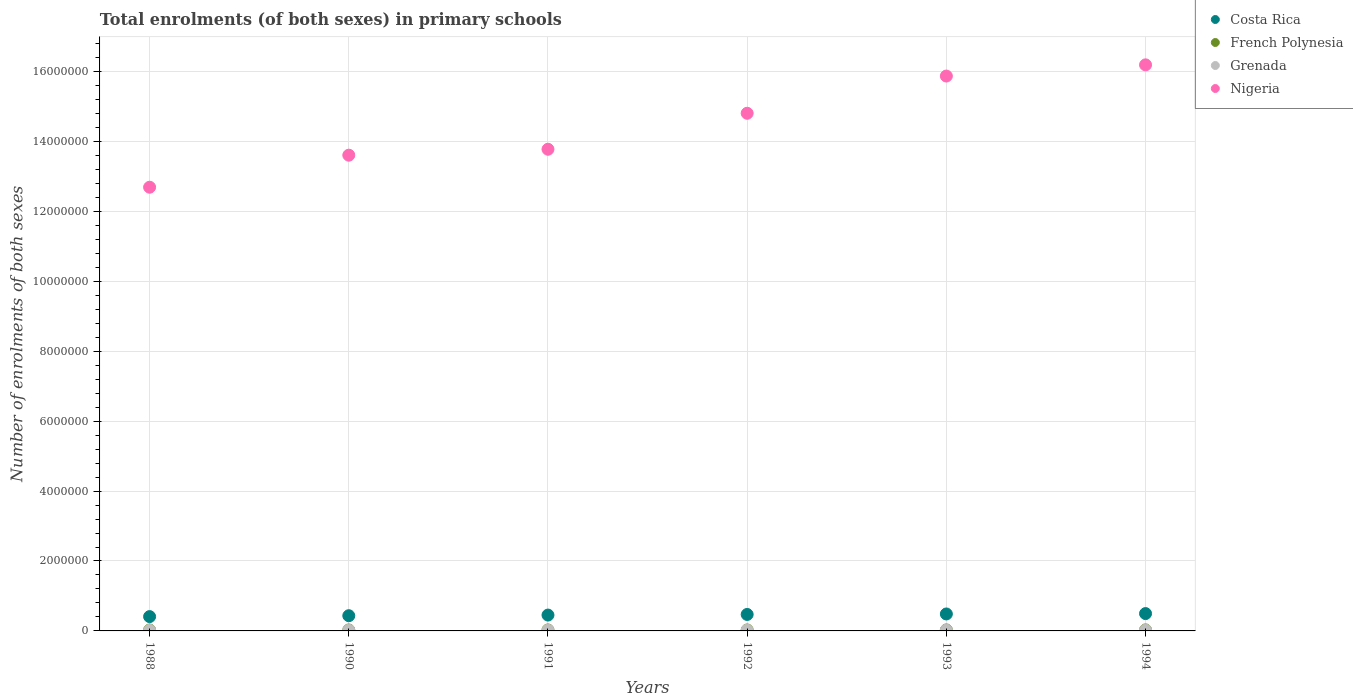Is the number of dotlines equal to the number of legend labels?
Give a very brief answer. Yes. What is the number of enrolments in primary schools in Costa Rica in 1993?
Your answer should be very brief. 4.85e+05. Across all years, what is the maximum number of enrolments in primary schools in Nigeria?
Offer a very short reply. 1.62e+07. Across all years, what is the minimum number of enrolments in primary schools in Nigeria?
Keep it short and to the point. 1.27e+07. In which year was the number of enrolments in primary schools in Nigeria maximum?
Your answer should be very brief. 1994. What is the total number of enrolments in primary schools in Grenada in the graph?
Your response must be concise. 1.24e+05. What is the difference between the number of enrolments in primary schools in Nigeria in 1990 and that in 1993?
Ensure brevity in your answer.  -2.26e+06. What is the difference between the number of enrolments in primary schools in Grenada in 1991 and the number of enrolments in primary schools in French Polynesia in 1992?
Your answer should be very brief. -8384. What is the average number of enrolments in primary schools in Nigeria per year?
Keep it short and to the point. 1.45e+07. In the year 1991, what is the difference between the number of enrolments in primary schools in Costa Rica and number of enrolments in primary schools in Grenada?
Offer a very short reply. 4.33e+05. In how many years, is the number of enrolments in primary schools in Grenada greater than 8400000?
Ensure brevity in your answer.  0. What is the ratio of the number of enrolments in primary schools in French Polynesia in 1993 to that in 1994?
Ensure brevity in your answer.  0.98. Is the difference between the number of enrolments in primary schools in Costa Rica in 1990 and 1994 greater than the difference between the number of enrolments in primary schools in Grenada in 1990 and 1994?
Offer a very short reply. No. What is the difference between the highest and the second highest number of enrolments in primary schools in French Polynesia?
Provide a succinct answer. 468. What is the difference between the highest and the lowest number of enrolments in primary schools in Costa Rica?
Your response must be concise. 8.63e+04. In how many years, is the number of enrolments in primary schools in Nigeria greater than the average number of enrolments in primary schools in Nigeria taken over all years?
Give a very brief answer. 3. Is the sum of the number of enrolments in primary schools in French Polynesia in 1990 and 1994 greater than the maximum number of enrolments in primary schools in Nigeria across all years?
Offer a very short reply. No. Is it the case that in every year, the sum of the number of enrolments in primary schools in Nigeria and number of enrolments in primary schools in Costa Rica  is greater than the sum of number of enrolments in primary schools in Grenada and number of enrolments in primary schools in French Polynesia?
Give a very brief answer. Yes. How many years are there in the graph?
Offer a very short reply. 6. Does the graph contain grids?
Offer a terse response. Yes. Where does the legend appear in the graph?
Make the answer very short. Top right. What is the title of the graph?
Ensure brevity in your answer.  Total enrolments (of both sexes) in primary schools. What is the label or title of the X-axis?
Offer a very short reply. Years. What is the label or title of the Y-axis?
Offer a very short reply. Number of enrolments of both sexes. What is the Number of enrolments of both sexes in Costa Rica in 1988?
Give a very brief answer. 4.10e+05. What is the Number of enrolments of both sexes of French Polynesia in 1988?
Provide a short and direct response. 2.73e+04. What is the Number of enrolments of both sexes of Grenada in 1988?
Offer a very short reply. 1.82e+04. What is the Number of enrolments of both sexes in Nigeria in 1988?
Make the answer very short. 1.27e+07. What is the Number of enrolments of both sexes of Costa Rica in 1990?
Make the answer very short. 4.35e+05. What is the Number of enrolments of both sexes of French Polynesia in 1990?
Ensure brevity in your answer.  2.79e+04. What is the Number of enrolments of both sexes of Grenada in 1990?
Your response must be concise. 1.92e+04. What is the Number of enrolments of both sexes of Nigeria in 1990?
Give a very brief answer. 1.36e+07. What is the Number of enrolments of both sexes of Costa Rica in 1991?
Provide a succinct answer. 4.53e+05. What is the Number of enrolments of both sexes in French Polynesia in 1991?
Keep it short and to the point. 2.83e+04. What is the Number of enrolments of both sexes in Grenada in 1991?
Make the answer very short. 1.98e+04. What is the Number of enrolments of both sexes of Nigeria in 1991?
Provide a short and direct response. 1.38e+07. What is the Number of enrolments of both sexes of Costa Rica in 1992?
Keep it short and to the point. 4.71e+05. What is the Number of enrolments of both sexes in French Polynesia in 1992?
Provide a short and direct response. 2.82e+04. What is the Number of enrolments of both sexes in Grenada in 1992?
Make the answer very short. 2.14e+04. What is the Number of enrolments of both sexes in Nigeria in 1992?
Provide a short and direct response. 1.48e+07. What is the Number of enrolments of both sexes of Costa Rica in 1993?
Your answer should be very brief. 4.85e+05. What is the Number of enrolments of both sexes of French Polynesia in 1993?
Your answer should be very brief. 2.91e+04. What is the Number of enrolments of both sexes of Grenada in 1993?
Your response must be concise. 2.23e+04. What is the Number of enrolments of both sexes in Nigeria in 1993?
Offer a terse response. 1.59e+07. What is the Number of enrolments of both sexes of Costa Rica in 1994?
Your answer should be compact. 4.96e+05. What is the Number of enrolments of both sexes in French Polynesia in 1994?
Provide a short and direct response. 2.96e+04. What is the Number of enrolments of both sexes of Grenada in 1994?
Offer a very short reply. 2.26e+04. What is the Number of enrolments of both sexes in Nigeria in 1994?
Provide a short and direct response. 1.62e+07. Across all years, what is the maximum Number of enrolments of both sexes in Costa Rica?
Your answer should be compact. 4.96e+05. Across all years, what is the maximum Number of enrolments of both sexes of French Polynesia?
Provide a succinct answer. 2.96e+04. Across all years, what is the maximum Number of enrolments of both sexes in Grenada?
Your response must be concise. 2.26e+04. Across all years, what is the maximum Number of enrolments of both sexes in Nigeria?
Provide a succinct answer. 1.62e+07. Across all years, what is the minimum Number of enrolments of both sexes in Costa Rica?
Provide a short and direct response. 4.10e+05. Across all years, what is the minimum Number of enrolments of both sexes in French Polynesia?
Keep it short and to the point. 2.73e+04. Across all years, what is the minimum Number of enrolments of both sexes in Grenada?
Offer a very short reply. 1.82e+04. Across all years, what is the minimum Number of enrolments of both sexes of Nigeria?
Your answer should be compact. 1.27e+07. What is the total Number of enrolments of both sexes in Costa Rica in the graph?
Your response must be concise. 2.75e+06. What is the total Number of enrolments of both sexes of French Polynesia in the graph?
Give a very brief answer. 1.70e+05. What is the total Number of enrolments of both sexes in Grenada in the graph?
Provide a succinct answer. 1.24e+05. What is the total Number of enrolments of both sexes in Nigeria in the graph?
Give a very brief answer. 8.69e+07. What is the difference between the Number of enrolments of both sexes in Costa Rica in 1988 and that in 1990?
Offer a very short reply. -2.56e+04. What is the difference between the Number of enrolments of both sexes in French Polynesia in 1988 and that in 1990?
Keep it short and to the point. -595. What is the difference between the Number of enrolments of both sexes of Grenada in 1988 and that in 1990?
Offer a terse response. -949. What is the difference between the Number of enrolments of both sexes of Nigeria in 1988 and that in 1990?
Offer a very short reply. -9.16e+05. What is the difference between the Number of enrolments of both sexes in Costa Rica in 1988 and that in 1991?
Offer a terse response. -4.37e+04. What is the difference between the Number of enrolments of both sexes of French Polynesia in 1988 and that in 1991?
Keep it short and to the point. -1011. What is the difference between the Number of enrolments of both sexes in Grenada in 1988 and that in 1991?
Provide a succinct answer. -1580. What is the difference between the Number of enrolments of both sexes in Nigeria in 1988 and that in 1991?
Keep it short and to the point. -1.09e+06. What is the difference between the Number of enrolments of both sexes in Costa Rica in 1988 and that in 1992?
Give a very brief answer. -6.14e+04. What is the difference between the Number of enrolments of both sexes of French Polynesia in 1988 and that in 1992?
Keep it short and to the point. -936. What is the difference between the Number of enrolments of both sexes of Grenada in 1988 and that in 1992?
Your response must be concise. -3134. What is the difference between the Number of enrolments of both sexes of Nigeria in 1988 and that in 1992?
Your answer should be compact. -2.12e+06. What is the difference between the Number of enrolments of both sexes in Costa Rica in 1988 and that in 1993?
Keep it short and to the point. -7.53e+04. What is the difference between the Number of enrolments of both sexes of French Polynesia in 1988 and that in 1993?
Make the answer very short. -1873. What is the difference between the Number of enrolments of both sexes in Grenada in 1988 and that in 1993?
Make the answer very short. -4114. What is the difference between the Number of enrolments of both sexes in Nigeria in 1988 and that in 1993?
Your answer should be compact. -3.18e+06. What is the difference between the Number of enrolments of both sexes in Costa Rica in 1988 and that in 1994?
Keep it short and to the point. -8.63e+04. What is the difference between the Number of enrolments of both sexes of French Polynesia in 1988 and that in 1994?
Your answer should be compact. -2341. What is the difference between the Number of enrolments of both sexes of Grenada in 1988 and that in 1994?
Give a very brief answer. -4345. What is the difference between the Number of enrolments of both sexes of Nigeria in 1988 and that in 1994?
Offer a very short reply. -3.50e+06. What is the difference between the Number of enrolments of both sexes in Costa Rica in 1990 and that in 1991?
Your answer should be compact. -1.81e+04. What is the difference between the Number of enrolments of both sexes in French Polynesia in 1990 and that in 1991?
Offer a very short reply. -416. What is the difference between the Number of enrolments of both sexes of Grenada in 1990 and that in 1991?
Offer a very short reply. -631. What is the difference between the Number of enrolments of both sexes of Nigeria in 1990 and that in 1991?
Keep it short and to the point. -1.70e+05. What is the difference between the Number of enrolments of both sexes of Costa Rica in 1990 and that in 1992?
Provide a short and direct response. -3.58e+04. What is the difference between the Number of enrolments of both sexes of French Polynesia in 1990 and that in 1992?
Ensure brevity in your answer.  -341. What is the difference between the Number of enrolments of both sexes in Grenada in 1990 and that in 1992?
Your response must be concise. -2185. What is the difference between the Number of enrolments of both sexes of Nigeria in 1990 and that in 1992?
Offer a very short reply. -1.20e+06. What is the difference between the Number of enrolments of both sexes of Costa Rica in 1990 and that in 1993?
Provide a short and direct response. -4.98e+04. What is the difference between the Number of enrolments of both sexes of French Polynesia in 1990 and that in 1993?
Offer a terse response. -1278. What is the difference between the Number of enrolments of both sexes in Grenada in 1990 and that in 1993?
Your response must be concise. -3165. What is the difference between the Number of enrolments of both sexes in Nigeria in 1990 and that in 1993?
Provide a short and direct response. -2.26e+06. What is the difference between the Number of enrolments of both sexes in Costa Rica in 1990 and that in 1994?
Your answer should be very brief. -6.07e+04. What is the difference between the Number of enrolments of both sexes in French Polynesia in 1990 and that in 1994?
Your answer should be very brief. -1746. What is the difference between the Number of enrolments of both sexes of Grenada in 1990 and that in 1994?
Your answer should be compact. -3396. What is the difference between the Number of enrolments of both sexes of Nigeria in 1990 and that in 1994?
Your answer should be compact. -2.58e+06. What is the difference between the Number of enrolments of both sexes in Costa Rica in 1991 and that in 1992?
Give a very brief answer. -1.78e+04. What is the difference between the Number of enrolments of both sexes in French Polynesia in 1991 and that in 1992?
Keep it short and to the point. 75. What is the difference between the Number of enrolments of both sexes in Grenada in 1991 and that in 1992?
Your answer should be compact. -1554. What is the difference between the Number of enrolments of both sexes of Nigeria in 1991 and that in 1992?
Give a very brief answer. -1.03e+06. What is the difference between the Number of enrolments of both sexes in Costa Rica in 1991 and that in 1993?
Make the answer very short. -3.17e+04. What is the difference between the Number of enrolments of both sexes in French Polynesia in 1991 and that in 1993?
Your answer should be compact. -862. What is the difference between the Number of enrolments of both sexes of Grenada in 1991 and that in 1993?
Ensure brevity in your answer.  -2534. What is the difference between the Number of enrolments of both sexes in Nigeria in 1991 and that in 1993?
Keep it short and to the point. -2.09e+06. What is the difference between the Number of enrolments of both sexes in Costa Rica in 1991 and that in 1994?
Give a very brief answer. -4.26e+04. What is the difference between the Number of enrolments of both sexes in French Polynesia in 1991 and that in 1994?
Make the answer very short. -1330. What is the difference between the Number of enrolments of both sexes of Grenada in 1991 and that in 1994?
Make the answer very short. -2765. What is the difference between the Number of enrolments of both sexes of Nigeria in 1991 and that in 1994?
Keep it short and to the point. -2.41e+06. What is the difference between the Number of enrolments of both sexes in Costa Rica in 1992 and that in 1993?
Keep it short and to the point. -1.39e+04. What is the difference between the Number of enrolments of both sexes of French Polynesia in 1992 and that in 1993?
Provide a short and direct response. -937. What is the difference between the Number of enrolments of both sexes in Grenada in 1992 and that in 1993?
Your answer should be compact. -980. What is the difference between the Number of enrolments of both sexes of Nigeria in 1992 and that in 1993?
Your answer should be compact. -1.06e+06. What is the difference between the Number of enrolments of both sexes in Costa Rica in 1992 and that in 1994?
Your answer should be very brief. -2.48e+04. What is the difference between the Number of enrolments of both sexes in French Polynesia in 1992 and that in 1994?
Ensure brevity in your answer.  -1405. What is the difference between the Number of enrolments of both sexes of Grenada in 1992 and that in 1994?
Your response must be concise. -1211. What is the difference between the Number of enrolments of both sexes of Nigeria in 1992 and that in 1994?
Offer a terse response. -1.39e+06. What is the difference between the Number of enrolments of both sexes of Costa Rica in 1993 and that in 1994?
Offer a terse response. -1.09e+04. What is the difference between the Number of enrolments of both sexes in French Polynesia in 1993 and that in 1994?
Offer a terse response. -468. What is the difference between the Number of enrolments of both sexes of Grenada in 1993 and that in 1994?
Provide a short and direct response. -231. What is the difference between the Number of enrolments of both sexes in Nigeria in 1993 and that in 1994?
Your response must be concise. -3.21e+05. What is the difference between the Number of enrolments of both sexes of Costa Rica in 1988 and the Number of enrolments of both sexes of French Polynesia in 1990?
Your answer should be compact. 3.82e+05. What is the difference between the Number of enrolments of both sexes of Costa Rica in 1988 and the Number of enrolments of both sexes of Grenada in 1990?
Your answer should be compact. 3.90e+05. What is the difference between the Number of enrolments of both sexes in Costa Rica in 1988 and the Number of enrolments of both sexes in Nigeria in 1990?
Ensure brevity in your answer.  -1.32e+07. What is the difference between the Number of enrolments of both sexes of French Polynesia in 1988 and the Number of enrolments of both sexes of Grenada in 1990?
Make the answer very short. 8079. What is the difference between the Number of enrolments of both sexes in French Polynesia in 1988 and the Number of enrolments of both sexes in Nigeria in 1990?
Make the answer very short. -1.36e+07. What is the difference between the Number of enrolments of both sexes of Grenada in 1988 and the Number of enrolments of both sexes of Nigeria in 1990?
Keep it short and to the point. -1.36e+07. What is the difference between the Number of enrolments of both sexes of Costa Rica in 1988 and the Number of enrolments of both sexes of French Polynesia in 1991?
Give a very brief answer. 3.81e+05. What is the difference between the Number of enrolments of both sexes in Costa Rica in 1988 and the Number of enrolments of both sexes in Grenada in 1991?
Your answer should be compact. 3.90e+05. What is the difference between the Number of enrolments of both sexes of Costa Rica in 1988 and the Number of enrolments of both sexes of Nigeria in 1991?
Provide a short and direct response. -1.34e+07. What is the difference between the Number of enrolments of both sexes of French Polynesia in 1988 and the Number of enrolments of both sexes of Grenada in 1991?
Make the answer very short. 7448. What is the difference between the Number of enrolments of both sexes in French Polynesia in 1988 and the Number of enrolments of both sexes in Nigeria in 1991?
Offer a terse response. -1.37e+07. What is the difference between the Number of enrolments of both sexes in Grenada in 1988 and the Number of enrolments of both sexes in Nigeria in 1991?
Make the answer very short. -1.38e+07. What is the difference between the Number of enrolments of both sexes of Costa Rica in 1988 and the Number of enrolments of both sexes of French Polynesia in 1992?
Your answer should be compact. 3.81e+05. What is the difference between the Number of enrolments of both sexes of Costa Rica in 1988 and the Number of enrolments of both sexes of Grenada in 1992?
Offer a terse response. 3.88e+05. What is the difference between the Number of enrolments of both sexes in Costa Rica in 1988 and the Number of enrolments of both sexes in Nigeria in 1992?
Keep it short and to the point. -1.44e+07. What is the difference between the Number of enrolments of both sexes in French Polynesia in 1988 and the Number of enrolments of both sexes in Grenada in 1992?
Provide a succinct answer. 5894. What is the difference between the Number of enrolments of both sexes in French Polynesia in 1988 and the Number of enrolments of both sexes in Nigeria in 1992?
Offer a very short reply. -1.48e+07. What is the difference between the Number of enrolments of both sexes of Grenada in 1988 and the Number of enrolments of both sexes of Nigeria in 1992?
Keep it short and to the point. -1.48e+07. What is the difference between the Number of enrolments of both sexes in Costa Rica in 1988 and the Number of enrolments of both sexes in French Polynesia in 1993?
Ensure brevity in your answer.  3.80e+05. What is the difference between the Number of enrolments of both sexes of Costa Rica in 1988 and the Number of enrolments of both sexes of Grenada in 1993?
Offer a terse response. 3.87e+05. What is the difference between the Number of enrolments of both sexes of Costa Rica in 1988 and the Number of enrolments of both sexes of Nigeria in 1993?
Offer a very short reply. -1.55e+07. What is the difference between the Number of enrolments of both sexes of French Polynesia in 1988 and the Number of enrolments of both sexes of Grenada in 1993?
Offer a very short reply. 4914. What is the difference between the Number of enrolments of both sexes in French Polynesia in 1988 and the Number of enrolments of both sexes in Nigeria in 1993?
Your response must be concise. -1.58e+07. What is the difference between the Number of enrolments of both sexes of Grenada in 1988 and the Number of enrolments of both sexes of Nigeria in 1993?
Give a very brief answer. -1.59e+07. What is the difference between the Number of enrolments of both sexes in Costa Rica in 1988 and the Number of enrolments of both sexes in French Polynesia in 1994?
Offer a terse response. 3.80e+05. What is the difference between the Number of enrolments of both sexes in Costa Rica in 1988 and the Number of enrolments of both sexes in Grenada in 1994?
Your response must be concise. 3.87e+05. What is the difference between the Number of enrolments of both sexes of Costa Rica in 1988 and the Number of enrolments of both sexes of Nigeria in 1994?
Offer a very short reply. -1.58e+07. What is the difference between the Number of enrolments of both sexes in French Polynesia in 1988 and the Number of enrolments of both sexes in Grenada in 1994?
Ensure brevity in your answer.  4683. What is the difference between the Number of enrolments of both sexes of French Polynesia in 1988 and the Number of enrolments of both sexes of Nigeria in 1994?
Make the answer very short. -1.62e+07. What is the difference between the Number of enrolments of both sexes in Grenada in 1988 and the Number of enrolments of both sexes in Nigeria in 1994?
Ensure brevity in your answer.  -1.62e+07. What is the difference between the Number of enrolments of both sexes of Costa Rica in 1990 and the Number of enrolments of both sexes of French Polynesia in 1991?
Offer a terse response. 4.07e+05. What is the difference between the Number of enrolments of both sexes of Costa Rica in 1990 and the Number of enrolments of both sexes of Grenada in 1991?
Keep it short and to the point. 4.15e+05. What is the difference between the Number of enrolments of both sexes in Costa Rica in 1990 and the Number of enrolments of both sexes in Nigeria in 1991?
Offer a very short reply. -1.33e+07. What is the difference between the Number of enrolments of both sexes in French Polynesia in 1990 and the Number of enrolments of both sexes in Grenada in 1991?
Your answer should be very brief. 8043. What is the difference between the Number of enrolments of both sexes in French Polynesia in 1990 and the Number of enrolments of both sexes in Nigeria in 1991?
Give a very brief answer. -1.37e+07. What is the difference between the Number of enrolments of both sexes in Grenada in 1990 and the Number of enrolments of both sexes in Nigeria in 1991?
Offer a terse response. -1.38e+07. What is the difference between the Number of enrolments of both sexes of Costa Rica in 1990 and the Number of enrolments of both sexes of French Polynesia in 1992?
Provide a succinct answer. 4.07e+05. What is the difference between the Number of enrolments of both sexes of Costa Rica in 1990 and the Number of enrolments of both sexes of Grenada in 1992?
Ensure brevity in your answer.  4.14e+05. What is the difference between the Number of enrolments of both sexes of Costa Rica in 1990 and the Number of enrolments of both sexes of Nigeria in 1992?
Ensure brevity in your answer.  -1.44e+07. What is the difference between the Number of enrolments of both sexes in French Polynesia in 1990 and the Number of enrolments of both sexes in Grenada in 1992?
Give a very brief answer. 6489. What is the difference between the Number of enrolments of both sexes in French Polynesia in 1990 and the Number of enrolments of both sexes in Nigeria in 1992?
Provide a short and direct response. -1.48e+07. What is the difference between the Number of enrolments of both sexes in Grenada in 1990 and the Number of enrolments of both sexes in Nigeria in 1992?
Your answer should be very brief. -1.48e+07. What is the difference between the Number of enrolments of both sexes in Costa Rica in 1990 and the Number of enrolments of both sexes in French Polynesia in 1993?
Make the answer very short. 4.06e+05. What is the difference between the Number of enrolments of both sexes in Costa Rica in 1990 and the Number of enrolments of both sexes in Grenada in 1993?
Keep it short and to the point. 4.13e+05. What is the difference between the Number of enrolments of both sexes of Costa Rica in 1990 and the Number of enrolments of both sexes of Nigeria in 1993?
Ensure brevity in your answer.  -1.54e+07. What is the difference between the Number of enrolments of both sexes in French Polynesia in 1990 and the Number of enrolments of both sexes in Grenada in 1993?
Give a very brief answer. 5509. What is the difference between the Number of enrolments of both sexes in French Polynesia in 1990 and the Number of enrolments of both sexes in Nigeria in 1993?
Your answer should be very brief. -1.58e+07. What is the difference between the Number of enrolments of both sexes of Grenada in 1990 and the Number of enrolments of both sexes of Nigeria in 1993?
Offer a terse response. -1.59e+07. What is the difference between the Number of enrolments of both sexes of Costa Rica in 1990 and the Number of enrolments of both sexes of French Polynesia in 1994?
Keep it short and to the point. 4.06e+05. What is the difference between the Number of enrolments of both sexes of Costa Rica in 1990 and the Number of enrolments of both sexes of Grenada in 1994?
Offer a very short reply. 4.13e+05. What is the difference between the Number of enrolments of both sexes in Costa Rica in 1990 and the Number of enrolments of both sexes in Nigeria in 1994?
Your answer should be very brief. -1.58e+07. What is the difference between the Number of enrolments of both sexes in French Polynesia in 1990 and the Number of enrolments of both sexes in Grenada in 1994?
Your response must be concise. 5278. What is the difference between the Number of enrolments of both sexes in French Polynesia in 1990 and the Number of enrolments of both sexes in Nigeria in 1994?
Give a very brief answer. -1.62e+07. What is the difference between the Number of enrolments of both sexes in Grenada in 1990 and the Number of enrolments of both sexes in Nigeria in 1994?
Your response must be concise. -1.62e+07. What is the difference between the Number of enrolments of both sexes in Costa Rica in 1991 and the Number of enrolments of both sexes in French Polynesia in 1992?
Your answer should be very brief. 4.25e+05. What is the difference between the Number of enrolments of both sexes in Costa Rica in 1991 and the Number of enrolments of both sexes in Grenada in 1992?
Offer a very short reply. 4.32e+05. What is the difference between the Number of enrolments of both sexes in Costa Rica in 1991 and the Number of enrolments of both sexes in Nigeria in 1992?
Your answer should be compact. -1.44e+07. What is the difference between the Number of enrolments of both sexes of French Polynesia in 1991 and the Number of enrolments of both sexes of Grenada in 1992?
Provide a short and direct response. 6905. What is the difference between the Number of enrolments of both sexes in French Polynesia in 1991 and the Number of enrolments of both sexes in Nigeria in 1992?
Your answer should be very brief. -1.48e+07. What is the difference between the Number of enrolments of both sexes in Grenada in 1991 and the Number of enrolments of both sexes in Nigeria in 1992?
Ensure brevity in your answer.  -1.48e+07. What is the difference between the Number of enrolments of both sexes of Costa Rica in 1991 and the Number of enrolments of both sexes of French Polynesia in 1993?
Your answer should be compact. 4.24e+05. What is the difference between the Number of enrolments of both sexes in Costa Rica in 1991 and the Number of enrolments of both sexes in Grenada in 1993?
Your answer should be compact. 4.31e+05. What is the difference between the Number of enrolments of both sexes in Costa Rica in 1991 and the Number of enrolments of both sexes in Nigeria in 1993?
Provide a succinct answer. -1.54e+07. What is the difference between the Number of enrolments of both sexes of French Polynesia in 1991 and the Number of enrolments of both sexes of Grenada in 1993?
Offer a terse response. 5925. What is the difference between the Number of enrolments of both sexes of French Polynesia in 1991 and the Number of enrolments of both sexes of Nigeria in 1993?
Keep it short and to the point. -1.58e+07. What is the difference between the Number of enrolments of both sexes in Grenada in 1991 and the Number of enrolments of both sexes in Nigeria in 1993?
Keep it short and to the point. -1.59e+07. What is the difference between the Number of enrolments of both sexes in Costa Rica in 1991 and the Number of enrolments of both sexes in French Polynesia in 1994?
Your answer should be compact. 4.24e+05. What is the difference between the Number of enrolments of both sexes of Costa Rica in 1991 and the Number of enrolments of both sexes of Grenada in 1994?
Offer a terse response. 4.31e+05. What is the difference between the Number of enrolments of both sexes of Costa Rica in 1991 and the Number of enrolments of both sexes of Nigeria in 1994?
Provide a succinct answer. -1.57e+07. What is the difference between the Number of enrolments of both sexes in French Polynesia in 1991 and the Number of enrolments of both sexes in Grenada in 1994?
Offer a very short reply. 5694. What is the difference between the Number of enrolments of both sexes in French Polynesia in 1991 and the Number of enrolments of both sexes in Nigeria in 1994?
Provide a short and direct response. -1.62e+07. What is the difference between the Number of enrolments of both sexes of Grenada in 1991 and the Number of enrolments of both sexes of Nigeria in 1994?
Your answer should be very brief. -1.62e+07. What is the difference between the Number of enrolments of both sexes in Costa Rica in 1992 and the Number of enrolments of both sexes in French Polynesia in 1993?
Give a very brief answer. 4.42e+05. What is the difference between the Number of enrolments of both sexes of Costa Rica in 1992 and the Number of enrolments of both sexes of Grenada in 1993?
Provide a short and direct response. 4.49e+05. What is the difference between the Number of enrolments of both sexes of Costa Rica in 1992 and the Number of enrolments of both sexes of Nigeria in 1993?
Give a very brief answer. -1.54e+07. What is the difference between the Number of enrolments of both sexes of French Polynesia in 1992 and the Number of enrolments of both sexes of Grenada in 1993?
Provide a succinct answer. 5850. What is the difference between the Number of enrolments of both sexes in French Polynesia in 1992 and the Number of enrolments of both sexes in Nigeria in 1993?
Ensure brevity in your answer.  -1.58e+07. What is the difference between the Number of enrolments of both sexes in Grenada in 1992 and the Number of enrolments of both sexes in Nigeria in 1993?
Provide a succinct answer. -1.58e+07. What is the difference between the Number of enrolments of both sexes in Costa Rica in 1992 and the Number of enrolments of both sexes in French Polynesia in 1994?
Provide a short and direct response. 4.41e+05. What is the difference between the Number of enrolments of both sexes of Costa Rica in 1992 and the Number of enrolments of both sexes of Grenada in 1994?
Make the answer very short. 4.48e+05. What is the difference between the Number of enrolments of both sexes of Costa Rica in 1992 and the Number of enrolments of both sexes of Nigeria in 1994?
Keep it short and to the point. -1.57e+07. What is the difference between the Number of enrolments of both sexes in French Polynesia in 1992 and the Number of enrolments of both sexes in Grenada in 1994?
Provide a succinct answer. 5619. What is the difference between the Number of enrolments of both sexes of French Polynesia in 1992 and the Number of enrolments of both sexes of Nigeria in 1994?
Make the answer very short. -1.62e+07. What is the difference between the Number of enrolments of both sexes of Grenada in 1992 and the Number of enrolments of both sexes of Nigeria in 1994?
Make the answer very short. -1.62e+07. What is the difference between the Number of enrolments of both sexes of Costa Rica in 1993 and the Number of enrolments of both sexes of French Polynesia in 1994?
Ensure brevity in your answer.  4.55e+05. What is the difference between the Number of enrolments of both sexes of Costa Rica in 1993 and the Number of enrolments of both sexes of Grenada in 1994?
Make the answer very short. 4.62e+05. What is the difference between the Number of enrolments of both sexes in Costa Rica in 1993 and the Number of enrolments of both sexes in Nigeria in 1994?
Ensure brevity in your answer.  -1.57e+07. What is the difference between the Number of enrolments of both sexes of French Polynesia in 1993 and the Number of enrolments of both sexes of Grenada in 1994?
Keep it short and to the point. 6556. What is the difference between the Number of enrolments of both sexes of French Polynesia in 1993 and the Number of enrolments of both sexes of Nigeria in 1994?
Make the answer very short. -1.62e+07. What is the difference between the Number of enrolments of both sexes in Grenada in 1993 and the Number of enrolments of both sexes in Nigeria in 1994?
Keep it short and to the point. -1.62e+07. What is the average Number of enrolments of both sexes in Costa Rica per year?
Your response must be concise. 4.58e+05. What is the average Number of enrolments of both sexes of French Polynesia per year?
Ensure brevity in your answer.  2.84e+04. What is the average Number of enrolments of both sexes in Grenada per year?
Your response must be concise. 2.06e+04. What is the average Number of enrolments of both sexes of Nigeria per year?
Ensure brevity in your answer.  1.45e+07. In the year 1988, what is the difference between the Number of enrolments of both sexes in Costa Rica and Number of enrolments of both sexes in French Polynesia?
Give a very brief answer. 3.82e+05. In the year 1988, what is the difference between the Number of enrolments of both sexes of Costa Rica and Number of enrolments of both sexes of Grenada?
Provide a succinct answer. 3.91e+05. In the year 1988, what is the difference between the Number of enrolments of both sexes in Costa Rica and Number of enrolments of both sexes in Nigeria?
Keep it short and to the point. -1.23e+07. In the year 1988, what is the difference between the Number of enrolments of both sexes in French Polynesia and Number of enrolments of both sexes in Grenada?
Your answer should be very brief. 9028. In the year 1988, what is the difference between the Number of enrolments of both sexes in French Polynesia and Number of enrolments of both sexes in Nigeria?
Keep it short and to the point. -1.27e+07. In the year 1988, what is the difference between the Number of enrolments of both sexes in Grenada and Number of enrolments of both sexes in Nigeria?
Your answer should be very brief. -1.27e+07. In the year 1990, what is the difference between the Number of enrolments of both sexes of Costa Rica and Number of enrolments of both sexes of French Polynesia?
Your response must be concise. 4.07e+05. In the year 1990, what is the difference between the Number of enrolments of both sexes of Costa Rica and Number of enrolments of both sexes of Grenada?
Your answer should be compact. 4.16e+05. In the year 1990, what is the difference between the Number of enrolments of both sexes of Costa Rica and Number of enrolments of both sexes of Nigeria?
Give a very brief answer. -1.32e+07. In the year 1990, what is the difference between the Number of enrolments of both sexes of French Polynesia and Number of enrolments of both sexes of Grenada?
Provide a short and direct response. 8674. In the year 1990, what is the difference between the Number of enrolments of both sexes in French Polynesia and Number of enrolments of both sexes in Nigeria?
Provide a short and direct response. -1.36e+07. In the year 1990, what is the difference between the Number of enrolments of both sexes in Grenada and Number of enrolments of both sexes in Nigeria?
Ensure brevity in your answer.  -1.36e+07. In the year 1991, what is the difference between the Number of enrolments of both sexes in Costa Rica and Number of enrolments of both sexes in French Polynesia?
Provide a succinct answer. 4.25e+05. In the year 1991, what is the difference between the Number of enrolments of both sexes of Costa Rica and Number of enrolments of both sexes of Grenada?
Keep it short and to the point. 4.33e+05. In the year 1991, what is the difference between the Number of enrolments of both sexes in Costa Rica and Number of enrolments of both sexes in Nigeria?
Provide a succinct answer. -1.33e+07. In the year 1991, what is the difference between the Number of enrolments of both sexes in French Polynesia and Number of enrolments of both sexes in Grenada?
Provide a succinct answer. 8459. In the year 1991, what is the difference between the Number of enrolments of both sexes of French Polynesia and Number of enrolments of both sexes of Nigeria?
Ensure brevity in your answer.  -1.37e+07. In the year 1991, what is the difference between the Number of enrolments of both sexes in Grenada and Number of enrolments of both sexes in Nigeria?
Give a very brief answer. -1.38e+07. In the year 1992, what is the difference between the Number of enrolments of both sexes of Costa Rica and Number of enrolments of both sexes of French Polynesia?
Provide a succinct answer. 4.43e+05. In the year 1992, what is the difference between the Number of enrolments of both sexes in Costa Rica and Number of enrolments of both sexes in Grenada?
Your response must be concise. 4.50e+05. In the year 1992, what is the difference between the Number of enrolments of both sexes in Costa Rica and Number of enrolments of both sexes in Nigeria?
Your answer should be compact. -1.43e+07. In the year 1992, what is the difference between the Number of enrolments of both sexes in French Polynesia and Number of enrolments of both sexes in Grenada?
Your answer should be very brief. 6830. In the year 1992, what is the difference between the Number of enrolments of both sexes in French Polynesia and Number of enrolments of both sexes in Nigeria?
Offer a terse response. -1.48e+07. In the year 1992, what is the difference between the Number of enrolments of both sexes in Grenada and Number of enrolments of both sexes in Nigeria?
Provide a short and direct response. -1.48e+07. In the year 1993, what is the difference between the Number of enrolments of both sexes in Costa Rica and Number of enrolments of both sexes in French Polynesia?
Your answer should be very brief. 4.56e+05. In the year 1993, what is the difference between the Number of enrolments of both sexes in Costa Rica and Number of enrolments of both sexes in Grenada?
Provide a short and direct response. 4.63e+05. In the year 1993, what is the difference between the Number of enrolments of both sexes of Costa Rica and Number of enrolments of both sexes of Nigeria?
Your response must be concise. -1.54e+07. In the year 1993, what is the difference between the Number of enrolments of both sexes in French Polynesia and Number of enrolments of both sexes in Grenada?
Offer a terse response. 6787. In the year 1993, what is the difference between the Number of enrolments of both sexes in French Polynesia and Number of enrolments of both sexes in Nigeria?
Give a very brief answer. -1.58e+07. In the year 1993, what is the difference between the Number of enrolments of both sexes of Grenada and Number of enrolments of both sexes of Nigeria?
Offer a terse response. -1.58e+07. In the year 1994, what is the difference between the Number of enrolments of both sexes in Costa Rica and Number of enrolments of both sexes in French Polynesia?
Give a very brief answer. 4.66e+05. In the year 1994, what is the difference between the Number of enrolments of both sexes of Costa Rica and Number of enrolments of both sexes of Grenada?
Make the answer very short. 4.73e+05. In the year 1994, what is the difference between the Number of enrolments of both sexes of Costa Rica and Number of enrolments of both sexes of Nigeria?
Give a very brief answer. -1.57e+07. In the year 1994, what is the difference between the Number of enrolments of both sexes of French Polynesia and Number of enrolments of both sexes of Grenada?
Your answer should be compact. 7024. In the year 1994, what is the difference between the Number of enrolments of both sexes in French Polynesia and Number of enrolments of both sexes in Nigeria?
Your answer should be very brief. -1.62e+07. In the year 1994, what is the difference between the Number of enrolments of both sexes of Grenada and Number of enrolments of both sexes of Nigeria?
Give a very brief answer. -1.62e+07. What is the ratio of the Number of enrolments of both sexes in French Polynesia in 1988 to that in 1990?
Your answer should be compact. 0.98. What is the ratio of the Number of enrolments of both sexes in Grenada in 1988 to that in 1990?
Make the answer very short. 0.95. What is the ratio of the Number of enrolments of both sexes in Nigeria in 1988 to that in 1990?
Give a very brief answer. 0.93. What is the ratio of the Number of enrolments of both sexes in Costa Rica in 1988 to that in 1991?
Provide a short and direct response. 0.9. What is the ratio of the Number of enrolments of both sexes of French Polynesia in 1988 to that in 1991?
Your answer should be compact. 0.96. What is the ratio of the Number of enrolments of both sexes of Grenada in 1988 to that in 1991?
Provide a succinct answer. 0.92. What is the ratio of the Number of enrolments of both sexes of Nigeria in 1988 to that in 1991?
Ensure brevity in your answer.  0.92. What is the ratio of the Number of enrolments of both sexes of Costa Rica in 1988 to that in 1992?
Offer a terse response. 0.87. What is the ratio of the Number of enrolments of both sexes of French Polynesia in 1988 to that in 1992?
Keep it short and to the point. 0.97. What is the ratio of the Number of enrolments of both sexes of Grenada in 1988 to that in 1992?
Ensure brevity in your answer.  0.85. What is the ratio of the Number of enrolments of both sexes of Costa Rica in 1988 to that in 1993?
Give a very brief answer. 0.84. What is the ratio of the Number of enrolments of both sexes of French Polynesia in 1988 to that in 1993?
Your answer should be compact. 0.94. What is the ratio of the Number of enrolments of both sexes of Grenada in 1988 to that in 1993?
Offer a terse response. 0.82. What is the ratio of the Number of enrolments of both sexes of Nigeria in 1988 to that in 1993?
Your response must be concise. 0.8. What is the ratio of the Number of enrolments of both sexes in Costa Rica in 1988 to that in 1994?
Ensure brevity in your answer.  0.83. What is the ratio of the Number of enrolments of both sexes in French Polynesia in 1988 to that in 1994?
Offer a terse response. 0.92. What is the ratio of the Number of enrolments of both sexes in Grenada in 1988 to that in 1994?
Your response must be concise. 0.81. What is the ratio of the Number of enrolments of both sexes in Nigeria in 1988 to that in 1994?
Keep it short and to the point. 0.78. What is the ratio of the Number of enrolments of both sexes in Costa Rica in 1990 to that in 1991?
Ensure brevity in your answer.  0.96. What is the ratio of the Number of enrolments of both sexes of Grenada in 1990 to that in 1991?
Offer a very short reply. 0.97. What is the ratio of the Number of enrolments of both sexes of Costa Rica in 1990 to that in 1992?
Provide a short and direct response. 0.92. What is the ratio of the Number of enrolments of both sexes of French Polynesia in 1990 to that in 1992?
Your answer should be very brief. 0.99. What is the ratio of the Number of enrolments of both sexes of Grenada in 1990 to that in 1992?
Provide a succinct answer. 0.9. What is the ratio of the Number of enrolments of both sexes of Nigeria in 1990 to that in 1992?
Your response must be concise. 0.92. What is the ratio of the Number of enrolments of both sexes of Costa Rica in 1990 to that in 1993?
Ensure brevity in your answer.  0.9. What is the ratio of the Number of enrolments of both sexes of French Polynesia in 1990 to that in 1993?
Provide a succinct answer. 0.96. What is the ratio of the Number of enrolments of both sexes of Grenada in 1990 to that in 1993?
Offer a terse response. 0.86. What is the ratio of the Number of enrolments of both sexes of Nigeria in 1990 to that in 1993?
Keep it short and to the point. 0.86. What is the ratio of the Number of enrolments of both sexes in Costa Rica in 1990 to that in 1994?
Offer a terse response. 0.88. What is the ratio of the Number of enrolments of both sexes of French Polynesia in 1990 to that in 1994?
Your answer should be very brief. 0.94. What is the ratio of the Number of enrolments of both sexes of Grenada in 1990 to that in 1994?
Ensure brevity in your answer.  0.85. What is the ratio of the Number of enrolments of both sexes of Nigeria in 1990 to that in 1994?
Your response must be concise. 0.84. What is the ratio of the Number of enrolments of both sexes of Costa Rica in 1991 to that in 1992?
Offer a terse response. 0.96. What is the ratio of the Number of enrolments of both sexes in Grenada in 1991 to that in 1992?
Your response must be concise. 0.93. What is the ratio of the Number of enrolments of both sexes of Nigeria in 1991 to that in 1992?
Keep it short and to the point. 0.93. What is the ratio of the Number of enrolments of both sexes in Costa Rica in 1991 to that in 1993?
Make the answer very short. 0.93. What is the ratio of the Number of enrolments of both sexes in French Polynesia in 1991 to that in 1993?
Your answer should be very brief. 0.97. What is the ratio of the Number of enrolments of both sexes of Grenada in 1991 to that in 1993?
Ensure brevity in your answer.  0.89. What is the ratio of the Number of enrolments of both sexes in Nigeria in 1991 to that in 1993?
Provide a short and direct response. 0.87. What is the ratio of the Number of enrolments of both sexes in Costa Rica in 1991 to that in 1994?
Keep it short and to the point. 0.91. What is the ratio of the Number of enrolments of both sexes of French Polynesia in 1991 to that in 1994?
Your response must be concise. 0.96. What is the ratio of the Number of enrolments of both sexes of Grenada in 1991 to that in 1994?
Give a very brief answer. 0.88. What is the ratio of the Number of enrolments of both sexes in Nigeria in 1991 to that in 1994?
Keep it short and to the point. 0.85. What is the ratio of the Number of enrolments of both sexes in Costa Rica in 1992 to that in 1993?
Your response must be concise. 0.97. What is the ratio of the Number of enrolments of both sexes in French Polynesia in 1992 to that in 1993?
Provide a short and direct response. 0.97. What is the ratio of the Number of enrolments of both sexes of Grenada in 1992 to that in 1993?
Provide a short and direct response. 0.96. What is the ratio of the Number of enrolments of both sexes in Nigeria in 1992 to that in 1993?
Your response must be concise. 0.93. What is the ratio of the Number of enrolments of both sexes of Costa Rica in 1992 to that in 1994?
Offer a very short reply. 0.95. What is the ratio of the Number of enrolments of both sexes of French Polynesia in 1992 to that in 1994?
Your response must be concise. 0.95. What is the ratio of the Number of enrolments of both sexes in Grenada in 1992 to that in 1994?
Give a very brief answer. 0.95. What is the ratio of the Number of enrolments of both sexes in Nigeria in 1992 to that in 1994?
Give a very brief answer. 0.91. What is the ratio of the Number of enrolments of both sexes in French Polynesia in 1993 to that in 1994?
Keep it short and to the point. 0.98. What is the ratio of the Number of enrolments of both sexes of Grenada in 1993 to that in 1994?
Provide a short and direct response. 0.99. What is the ratio of the Number of enrolments of both sexes of Nigeria in 1993 to that in 1994?
Your response must be concise. 0.98. What is the difference between the highest and the second highest Number of enrolments of both sexes of Costa Rica?
Provide a short and direct response. 1.09e+04. What is the difference between the highest and the second highest Number of enrolments of both sexes in French Polynesia?
Give a very brief answer. 468. What is the difference between the highest and the second highest Number of enrolments of both sexes of Grenada?
Offer a terse response. 231. What is the difference between the highest and the second highest Number of enrolments of both sexes of Nigeria?
Keep it short and to the point. 3.21e+05. What is the difference between the highest and the lowest Number of enrolments of both sexes in Costa Rica?
Keep it short and to the point. 8.63e+04. What is the difference between the highest and the lowest Number of enrolments of both sexes in French Polynesia?
Provide a succinct answer. 2341. What is the difference between the highest and the lowest Number of enrolments of both sexes of Grenada?
Your answer should be very brief. 4345. What is the difference between the highest and the lowest Number of enrolments of both sexes of Nigeria?
Make the answer very short. 3.50e+06. 